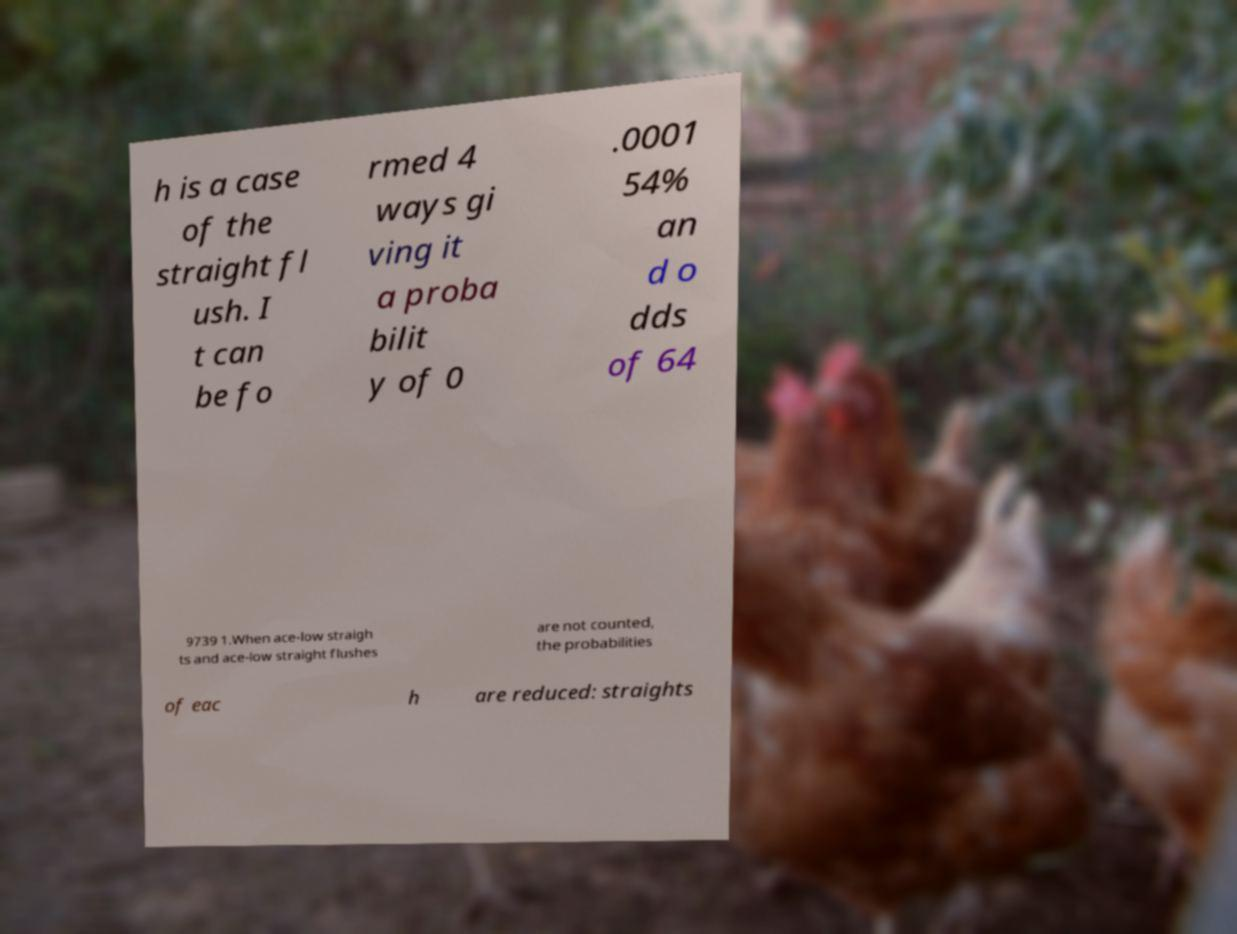Could you extract and type out the text from this image? h is a case of the straight fl ush. I t can be fo rmed 4 ways gi ving it a proba bilit y of 0 .0001 54% an d o dds of 64 9739 1.When ace-low straigh ts and ace-low straight flushes are not counted, the probabilities of eac h are reduced: straights 